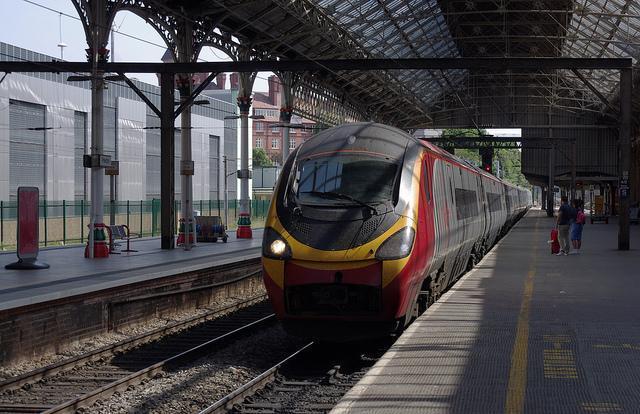How many lights are on the front of the train?
Give a very brief answer. 1. How many people are riding the bike farthest to the left?
Give a very brief answer. 0. 